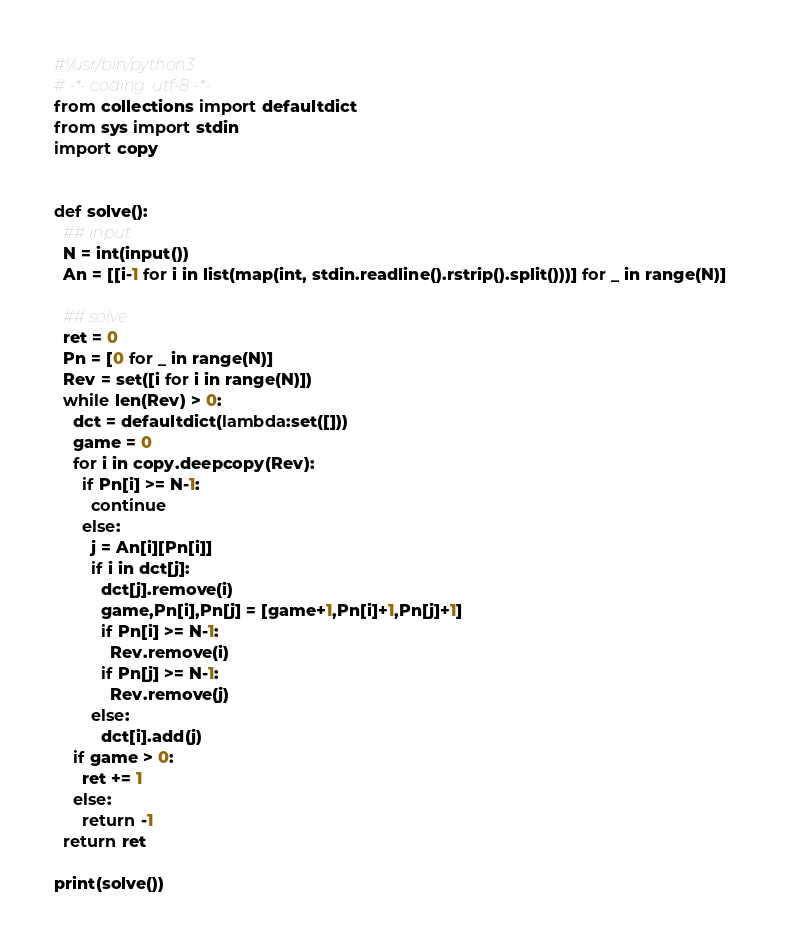Convert code to text. <code><loc_0><loc_0><loc_500><loc_500><_Python_>#!/usr/bin/python3
# -*- coding: utf-8 -*-
from collections import defaultdict
from sys import stdin
import copy


def solve():
  ## input
  N = int(input())
  An = [[i-1 for i in list(map(int, stdin.readline().rstrip().split()))] for _ in range(N)]  

  ## solve
  ret = 0
  Pn = [0 for _ in range(N)]
  Rev = set([i for i in range(N)])
  while len(Rev) > 0:
    dct = defaultdict(lambda:set([]))
    game = 0
    for i in copy.deepcopy(Rev):
      if Pn[i] >= N-1:
        continue
      else:
        j = An[i][Pn[i]]
        if i in dct[j]:
          dct[j].remove(i)
          game,Pn[i],Pn[j] = [game+1,Pn[i]+1,Pn[j]+1]
          if Pn[i] >= N-1:
            Rev.remove(i)
          if Pn[j] >= N-1:
            Rev.remove(j)
        else:
          dct[i].add(j)
    if game > 0:
      ret += 1
    else:
      return -1
  return ret

print(solve())
</code> 